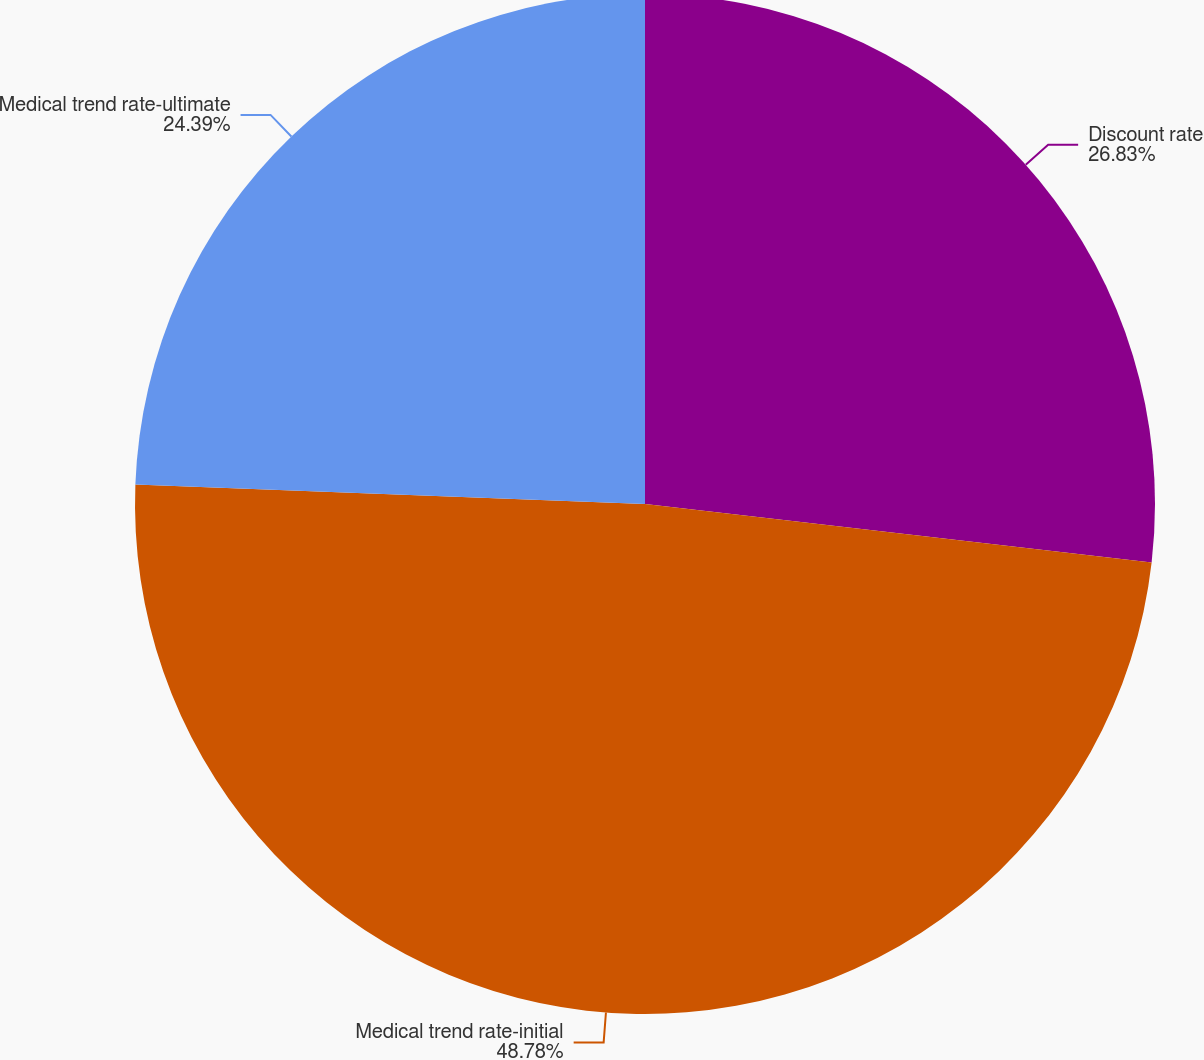Convert chart to OTSL. <chart><loc_0><loc_0><loc_500><loc_500><pie_chart><fcel>Discount rate<fcel>Medical trend rate-initial<fcel>Medical trend rate-ultimate<nl><fcel>26.83%<fcel>48.78%<fcel>24.39%<nl></chart> 